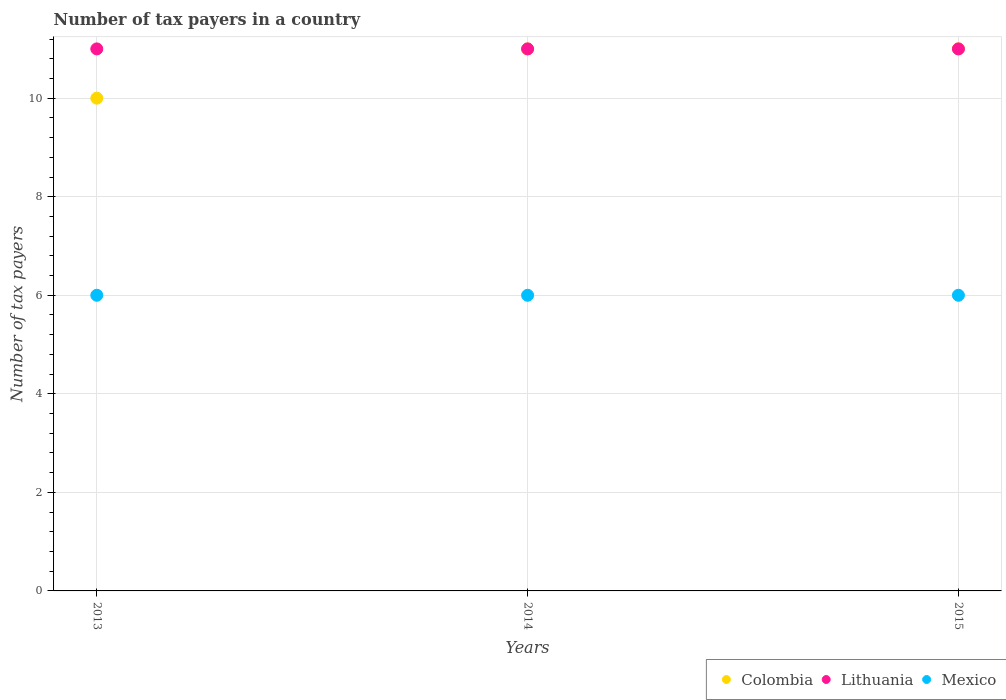How many different coloured dotlines are there?
Keep it short and to the point. 3. What is the number of tax payers in in Colombia in 2015?
Give a very brief answer. 11. In which year was the number of tax payers in in Lithuania maximum?
Your answer should be very brief. 2013. What is the total number of tax payers in in Lithuania in the graph?
Provide a succinct answer. 33. What is the difference between the number of tax payers in in Mexico in 2014 and that in 2015?
Your answer should be compact. 0. What is the difference between the number of tax payers in in Mexico in 2013 and the number of tax payers in in Lithuania in 2014?
Your response must be concise. -5. What is the average number of tax payers in in Colombia per year?
Provide a short and direct response. 10.67. In the year 2015, what is the difference between the number of tax payers in in Mexico and number of tax payers in in Lithuania?
Keep it short and to the point. -5. In how many years, is the number of tax payers in in Colombia greater than 2.8?
Give a very brief answer. 3. What is the ratio of the number of tax payers in in Lithuania in 2014 to that in 2015?
Your answer should be compact. 1. What is the difference between the highest and the lowest number of tax payers in in Mexico?
Your response must be concise. 0. Is the number of tax payers in in Lithuania strictly greater than the number of tax payers in in Mexico over the years?
Give a very brief answer. Yes. How many dotlines are there?
Your answer should be compact. 3. Are the values on the major ticks of Y-axis written in scientific E-notation?
Give a very brief answer. No. Does the graph contain any zero values?
Keep it short and to the point. No. Does the graph contain grids?
Keep it short and to the point. Yes. How many legend labels are there?
Make the answer very short. 3. How are the legend labels stacked?
Offer a very short reply. Horizontal. What is the title of the graph?
Your answer should be very brief. Number of tax payers in a country. What is the label or title of the Y-axis?
Your answer should be very brief. Number of tax payers. What is the Number of tax payers of Lithuania in 2013?
Keep it short and to the point. 11. What is the Number of tax payers of Colombia in 2014?
Offer a terse response. 11. What is the Number of tax payers in Mexico in 2014?
Your response must be concise. 6. What is the Number of tax payers in Colombia in 2015?
Provide a short and direct response. 11. Across all years, what is the maximum Number of tax payers of Colombia?
Make the answer very short. 11. Across all years, what is the maximum Number of tax payers of Mexico?
Make the answer very short. 6. Across all years, what is the minimum Number of tax payers in Lithuania?
Provide a succinct answer. 11. Across all years, what is the minimum Number of tax payers in Mexico?
Your answer should be very brief. 6. What is the total Number of tax payers of Mexico in the graph?
Offer a very short reply. 18. What is the difference between the Number of tax payers of Colombia in 2013 and that in 2014?
Offer a very short reply. -1. What is the difference between the Number of tax payers of Colombia in 2013 and that in 2015?
Keep it short and to the point. -1. What is the difference between the Number of tax payers of Lithuania in 2013 and that in 2015?
Provide a succinct answer. 0. What is the difference between the Number of tax payers in Lithuania in 2014 and that in 2015?
Offer a terse response. 0. What is the difference between the Number of tax payers in Lithuania in 2013 and the Number of tax payers in Mexico in 2014?
Your answer should be very brief. 5. What is the difference between the Number of tax payers in Colombia in 2013 and the Number of tax payers in Mexico in 2015?
Ensure brevity in your answer.  4. What is the difference between the Number of tax payers in Lithuania in 2013 and the Number of tax payers in Mexico in 2015?
Give a very brief answer. 5. What is the difference between the Number of tax payers of Colombia in 2014 and the Number of tax payers of Lithuania in 2015?
Your answer should be very brief. 0. What is the difference between the Number of tax payers in Lithuania in 2014 and the Number of tax payers in Mexico in 2015?
Your answer should be compact. 5. What is the average Number of tax payers in Colombia per year?
Offer a terse response. 10.67. What is the average Number of tax payers in Lithuania per year?
Give a very brief answer. 11. What is the average Number of tax payers in Mexico per year?
Ensure brevity in your answer.  6. In the year 2013, what is the difference between the Number of tax payers in Colombia and Number of tax payers in Lithuania?
Keep it short and to the point. -1. In the year 2013, what is the difference between the Number of tax payers of Lithuania and Number of tax payers of Mexico?
Make the answer very short. 5. In the year 2014, what is the difference between the Number of tax payers of Colombia and Number of tax payers of Mexico?
Your answer should be compact. 5. In the year 2015, what is the difference between the Number of tax payers in Lithuania and Number of tax payers in Mexico?
Ensure brevity in your answer.  5. What is the ratio of the Number of tax payers in Colombia in 2013 to that in 2014?
Make the answer very short. 0.91. What is the ratio of the Number of tax payers of Lithuania in 2013 to that in 2014?
Offer a very short reply. 1. What is the ratio of the Number of tax payers in Mexico in 2013 to that in 2014?
Your answer should be very brief. 1. What is the ratio of the Number of tax payers in Colombia in 2013 to that in 2015?
Provide a short and direct response. 0.91. What is the ratio of the Number of tax payers in Lithuania in 2013 to that in 2015?
Make the answer very short. 1. What is the ratio of the Number of tax payers of Mexico in 2013 to that in 2015?
Your answer should be very brief. 1. What is the ratio of the Number of tax payers in Mexico in 2014 to that in 2015?
Offer a very short reply. 1. What is the difference between the highest and the lowest Number of tax payers in Colombia?
Offer a terse response. 1. What is the difference between the highest and the lowest Number of tax payers in Lithuania?
Ensure brevity in your answer.  0. 